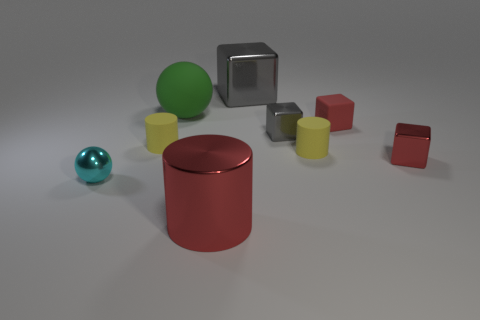Subtract 3 blocks. How many blocks are left? 1 Subtract all small gray blocks. How many blocks are left? 3 Add 1 red metallic cubes. How many objects exist? 10 Subtract all yellow cylinders. How many cylinders are left? 1 Subtract all blue cylinders. How many red blocks are left? 2 Subtract all blue rubber cubes. Subtract all green matte balls. How many objects are left? 8 Add 4 small cylinders. How many small cylinders are left? 6 Add 5 green matte things. How many green matte things exist? 6 Subtract 0 gray spheres. How many objects are left? 9 Subtract all cylinders. How many objects are left? 6 